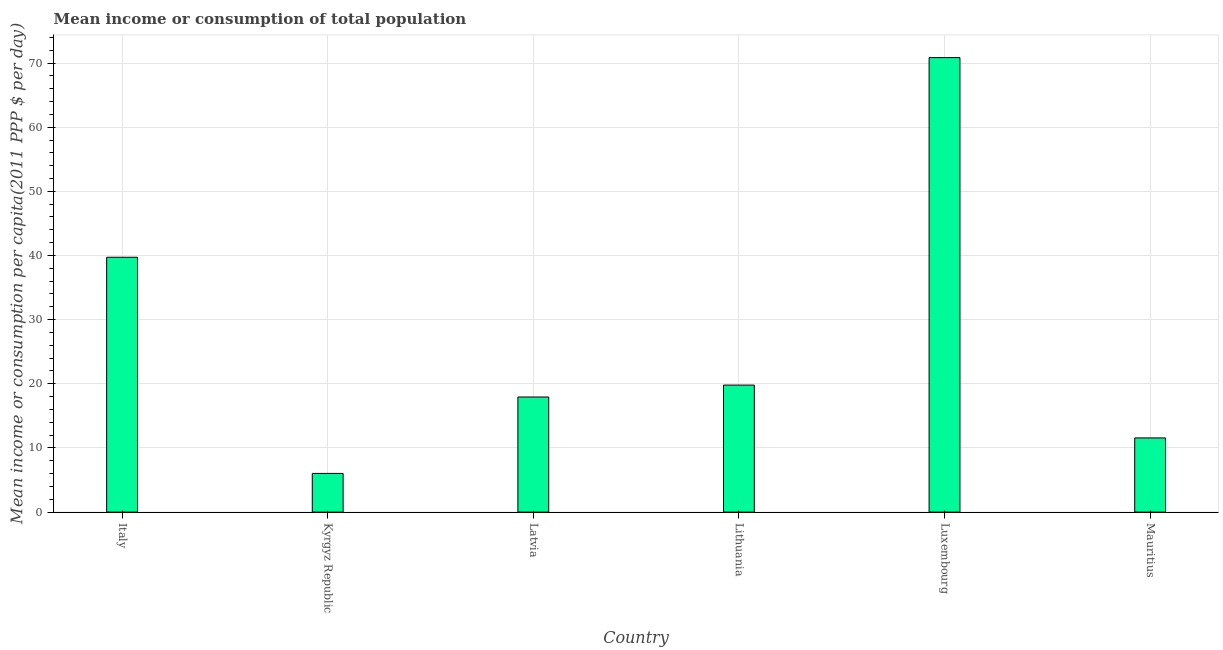Does the graph contain grids?
Provide a short and direct response. Yes. What is the title of the graph?
Offer a terse response. Mean income or consumption of total population. What is the label or title of the X-axis?
Ensure brevity in your answer.  Country. What is the label or title of the Y-axis?
Make the answer very short. Mean income or consumption per capita(2011 PPP $ per day). What is the mean income or consumption in Italy?
Give a very brief answer. 39.72. Across all countries, what is the maximum mean income or consumption?
Offer a very short reply. 70.85. Across all countries, what is the minimum mean income or consumption?
Keep it short and to the point. 6.02. In which country was the mean income or consumption maximum?
Provide a short and direct response. Luxembourg. In which country was the mean income or consumption minimum?
Provide a short and direct response. Kyrgyz Republic. What is the sum of the mean income or consumption?
Offer a terse response. 165.88. What is the difference between the mean income or consumption in Latvia and Lithuania?
Give a very brief answer. -1.85. What is the average mean income or consumption per country?
Provide a short and direct response. 27.65. What is the median mean income or consumption?
Provide a short and direct response. 18.86. What is the ratio of the mean income or consumption in Italy to that in Luxembourg?
Give a very brief answer. 0.56. Is the difference between the mean income or consumption in Latvia and Luxembourg greater than the difference between any two countries?
Give a very brief answer. No. What is the difference between the highest and the second highest mean income or consumption?
Your response must be concise. 31.13. Is the sum of the mean income or consumption in Italy and Mauritius greater than the maximum mean income or consumption across all countries?
Make the answer very short. No. What is the difference between the highest and the lowest mean income or consumption?
Provide a succinct answer. 64.83. Are all the bars in the graph horizontal?
Provide a short and direct response. No. How many countries are there in the graph?
Provide a succinct answer. 6. What is the Mean income or consumption per capita(2011 PPP $ per day) in Italy?
Offer a very short reply. 39.72. What is the Mean income or consumption per capita(2011 PPP $ per day) of Kyrgyz Republic?
Offer a very short reply. 6.02. What is the Mean income or consumption per capita(2011 PPP $ per day) in Latvia?
Offer a terse response. 17.94. What is the Mean income or consumption per capita(2011 PPP $ per day) in Lithuania?
Give a very brief answer. 19.79. What is the Mean income or consumption per capita(2011 PPP $ per day) of Luxembourg?
Ensure brevity in your answer.  70.85. What is the Mean income or consumption per capita(2011 PPP $ per day) of Mauritius?
Give a very brief answer. 11.56. What is the difference between the Mean income or consumption per capita(2011 PPP $ per day) in Italy and Kyrgyz Republic?
Your answer should be very brief. 33.7. What is the difference between the Mean income or consumption per capita(2011 PPP $ per day) in Italy and Latvia?
Keep it short and to the point. 21.79. What is the difference between the Mean income or consumption per capita(2011 PPP $ per day) in Italy and Lithuania?
Offer a very short reply. 19.93. What is the difference between the Mean income or consumption per capita(2011 PPP $ per day) in Italy and Luxembourg?
Ensure brevity in your answer.  -31.13. What is the difference between the Mean income or consumption per capita(2011 PPP $ per day) in Italy and Mauritius?
Your answer should be compact. 28.17. What is the difference between the Mean income or consumption per capita(2011 PPP $ per day) in Kyrgyz Republic and Latvia?
Give a very brief answer. -11.92. What is the difference between the Mean income or consumption per capita(2011 PPP $ per day) in Kyrgyz Republic and Lithuania?
Give a very brief answer. -13.77. What is the difference between the Mean income or consumption per capita(2011 PPP $ per day) in Kyrgyz Republic and Luxembourg?
Give a very brief answer. -64.83. What is the difference between the Mean income or consumption per capita(2011 PPP $ per day) in Kyrgyz Republic and Mauritius?
Your answer should be compact. -5.54. What is the difference between the Mean income or consumption per capita(2011 PPP $ per day) in Latvia and Lithuania?
Your answer should be compact. -1.86. What is the difference between the Mean income or consumption per capita(2011 PPP $ per day) in Latvia and Luxembourg?
Keep it short and to the point. -52.91. What is the difference between the Mean income or consumption per capita(2011 PPP $ per day) in Latvia and Mauritius?
Offer a terse response. 6.38. What is the difference between the Mean income or consumption per capita(2011 PPP $ per day) in Lithuania and Luxembourg?
Make the answer very short. -51.06. What is the difference between the Mean income or consumption per capita(2011 PPP $ per day) in Lithuania and Mauritius?
Offer a very short reply. 8.24. What is the difference between the Mean income or consumption per capita(2011 PPP $ per day) in Luxembourg and Mauritius?
Provide a succinct answer. 59.29. What is the ratio of the Mean income or consumption per capita(2011 PPP $ per day) in Italy to that in Kyrgyz Republic?
Your response must be concise. 6.6. What is the ratio of the Mean income or consumption per capita(2011 PPP $ per day) in Italy to that in Latvia?
Provide a short and direct response. 2.21. What is the ratio of the Mean income or consumption per capita(2011 PPP $ per day) in Italy to that in Lithuania?
Ensure brevity in your answer.  2.01. What is the ratio of the Mean income or consumption per capita(2011 PPP $ per day) in Italy to that in Luxembourg?
Ensure brevity in your answer.  0.56. What is the ratio of the Mean income or consumption per capita(2011 PPP $ per day) in Italy to that in Mauritius?
Ensure brevity in your answer.  3.44. What is the ratio of the Mean income or consumption per capita(2011 PPP $ per day) in Kyrgyz Republic to that in Latvia?
Your answer should be very brief. 0.34. What is the ratio of the Mean income or consumption per capita(2011 PPP $ per day) in Kyrgyz Republic to that in Lithuania?
Provide a succinct answer. 0.3. What is the ratio of the Mean income or consumption per capita(2011 PPP $ per day) in Kyrgyz Republic to that in Luxembourg?
Your response must be concise. 0.09. What is the ratio of the Mean income or consumption per capita(2011 PPP $ per day) in Kyrgyz Republic to that in Mauritius?
Offer a very short reply. 0.52. What is the ratio of the Mean income or consumption per capita(2011 PPP $ per day) in Latvia to that in Lithuania?
Provide a succinct answer. 0.91. What is the ratio of the Mean income or consumption per capita(2011 PPP $ per day) in Latvia to that in Luxembourg?
Provide a succinct answer. 0.25. What is the ratio of the Mean income or consumption per capita(2011 PPP $ per day) in Latvia to that in Mauritius?
Provide a short and direct response. 1.55. What is the ratio of the Mean income or consumption per capita(2011 PPP $ per day) in Lithuania to that in Luxembourg?
Your response must be concise. 0.28. What is the ratio of the Mean income or consumption per capita(2011 PPP $ per day) in Lithuania to that in Mauritius?
Provide a short and direct response. 1.71. What is the ratio of the Mean income or consumption per capita(2011 PPP $ per day) in Luxembourg to that in Mauritius?
Give a very brief answer. 6.13. 